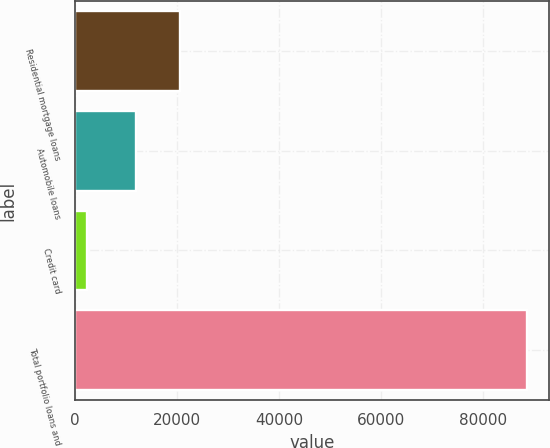<chart> <loc_0><loc_0><loc_500><loc_500><bar_chart><fcel>Residential mortgage loans<fcel>Automobile loans<fcel>Credit card<fcel>Total portfolio loans and<nl><fcel>20606.8<fcel>11984<fcel>2294<fcel>88522<nl></chart> 